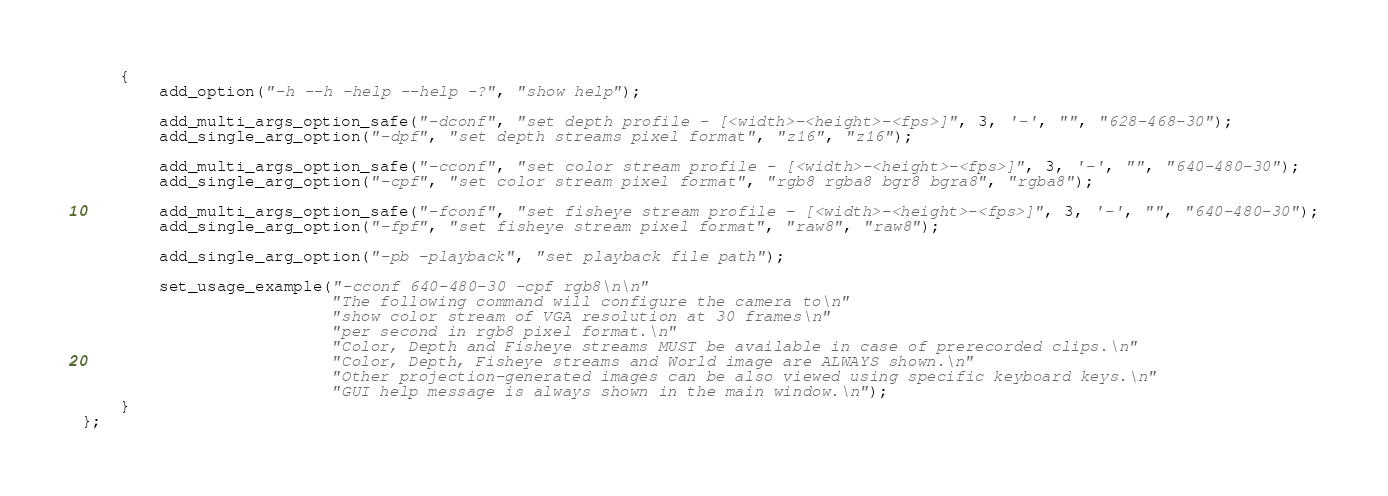<code> <loc_0><loc_0><loc_500><loc_500><_C_>    {
        add_option("-h --h -help --help -?", "show help");
    
        add_multi_args_option_safe("-dconf", "set depth profile - [<width>-<height>-<fps>]", 3, '-', "", "628-468-30");
        add_single_arg_option("-dpf", "set depth streams pixel format", "z16", "z16");
    
        add_multi_args_option_safe("-cconf", "set color stream profile - [<width>-<height>-<fps>]", 3, '-', "", "640-480-30");
        add_single_arg_option("-cpf", "set color stream pixel format", "rgb8 rgba8 bgr8 bgra8", "rgba8");
    
        add_multi_args_option_safe("-fconf", "set fisheye stream profile - [<width>-<height>-<fps>]", 3, '-', "", "640-480-30");
        add_single_arg_option("-fpf", "set fisheye stream pixel format", "raw8", "raw8");

        add_single_arg_option("-pb -playback", "set playback file path");

        set_usage_example("-cconf 640-480-30 -cpf rgb8\n\n"
                          "The following command will configure the camera to\n"
                          "show color stream of VGA resolution at 30 frames\n"
                          "per second in rgb8 pixel format.\n"
                          "Color, Depth and Fisheye streams MUST be available in case of prerecorded clips.\n"
                          "Color, Depth, Fisheye streams and World image are ALWAYS shown.\n"
                          "Other projection-generated images can be also viewed using specific keyboard keys.\n"
                          "GUI help message is always shown in the main window.\n");
    }
};
</code> 